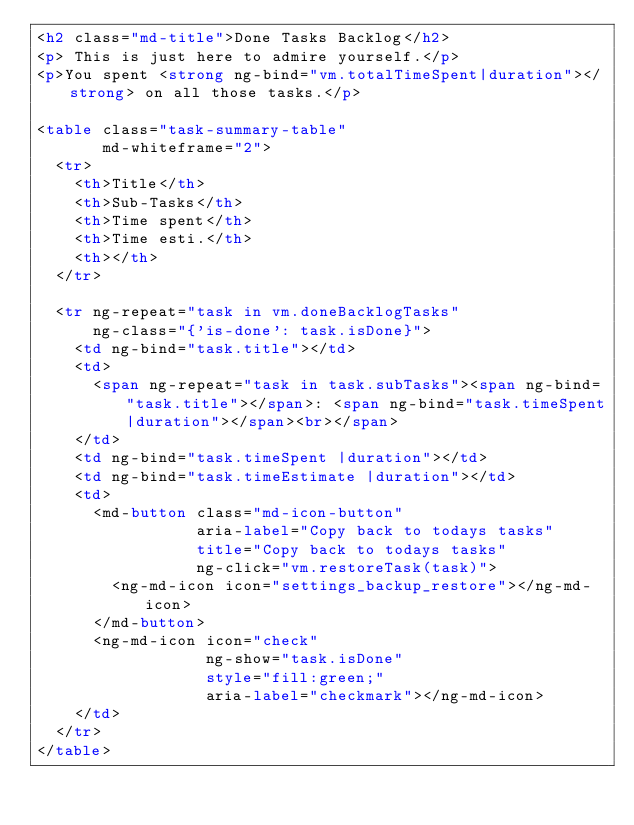<code> <loc_0><loc_0><loc_500><loc_500><_HTML_><h2 class="md-title">Done Tasks Backlog</h2>
<p> This is just here to admire yourself.</p>
<p>You spent <strong ng-bind="vm.totalTimeSpent|duration"></strong> on all those tasks.</p>

<table class="task-summary-table"
       md-whiteframe="2">
  <tr>
    <th>Title</th>
    <th>Sub-Tasks</th>
    <th>Time spent</th>
    <th>Time esti.</th>
    <th></th>
  </tr>

  <tr ng-repeat="task in vm.doneBacklogTasks"
      ng-class="{'is-done': task.isDone}">
    <td ng-bind="task.title"></td>
    <td>
      <span ng-repeat="task in task.subTasks"><span ng-bind="task.title"></span>: <span ng-bind="task.timeSpent|duration"></span><br></span>
    </td>
    <td ng-bind="task.timeSpent |duration"></td>
    <td ng-bind="task.timeEstimate |duration"></td>
    <td>
      <md-button class="md-icon-button"
                 aria-label="Copy back to todays tasks"
                 title="Copy back to todays tasks"
                 ng-click="vm.restoreTask(task)">
        <ng-md-icon icon="settings_backup_restore"></ng-md-icon>
      </md-button>
      <ng-md-icon icon="check"
                  ng-show="task.isDone"
                  style="fill:green;"
                  aria-label="checkmark"></ng-md-icon>
    </td>
  </tr>
</table></code> 